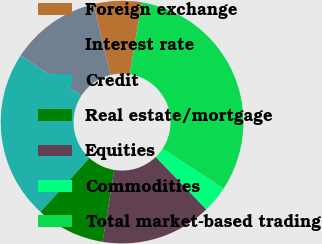Convert chart to OTSL. <chart><loc_0><loc_0><loc_500><loc_500><pie_chart><fcel>Foreign exchange<fcel>Interest rate<fcel>Credit<fcel>Real estate/mortgage<fcel>Equities<fcel>Commodities<fcel>Total market-based trading<nl><fcel>6.37%<fcel>11.98%<fcel>22.5%<fcel>9.17%<fcel>14.79%<fcel>3.56%<fcel>31.63%<nl></chart> 